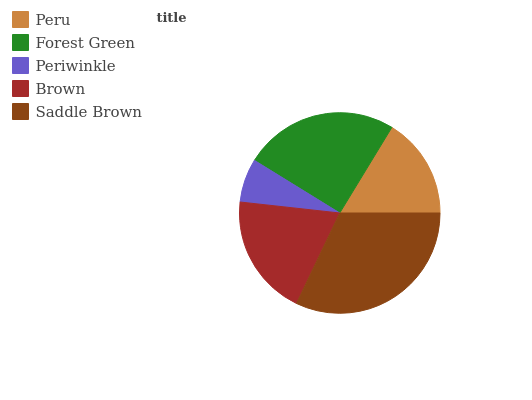Is Periwinkle the minimum?
Answer yes or no. Yes. Is Saddle Brown the maximum?
Answer yes or no. Yes. Is Forest Green the minimum?
Answer yes or no. No. Is Forest Green the maximum?
Answer yes or no. No. Is Forest Green greater than Peru?
Answer yes or no. Yes. Is Peru less than Forest Green?
Answer yes or no. Yes. Is Peru greater than Forest Green?
Answer yes or no. No. Is Forest Green less than Peru?
Answer yes or no. No. Is Brown the high median?
Answer yes or no. Yes. Is Brown the low median?
Answer yes or no. Yes. Is Saddle Brown the high median?
Answer yes or no. No. Is Forest Green the low median?
Answer yes or no. No. 